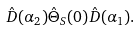<formula> <loc_0><loc_0><loc_500><loc_500>\hat { D } ( \alpha _ { 2 } ) \hat { \Theta } _ { S } ( 0 ) \hat { D } ( \alpha _ { 1 } ) .</formula> 